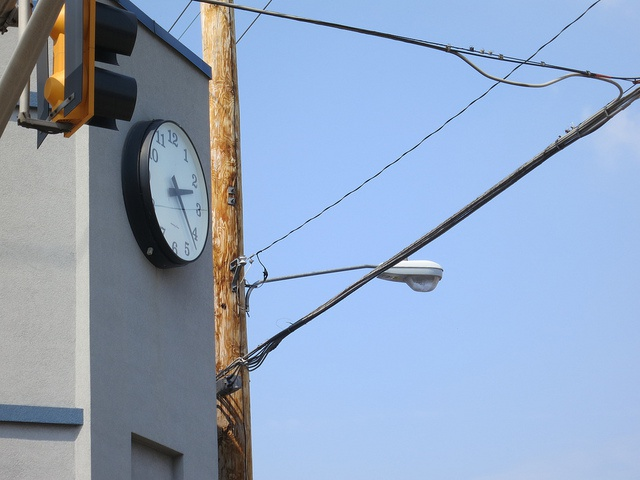Describe the objects in this image and their specific colors. I can see traffic light in black, gray, maroon, and brown tones and clock in black, lightblue, darkgray, and gray tones in this image. 